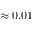<formula> <loc_0><loc_0><loc_500><loc_500>\approx 0 . 0 1</formula> 